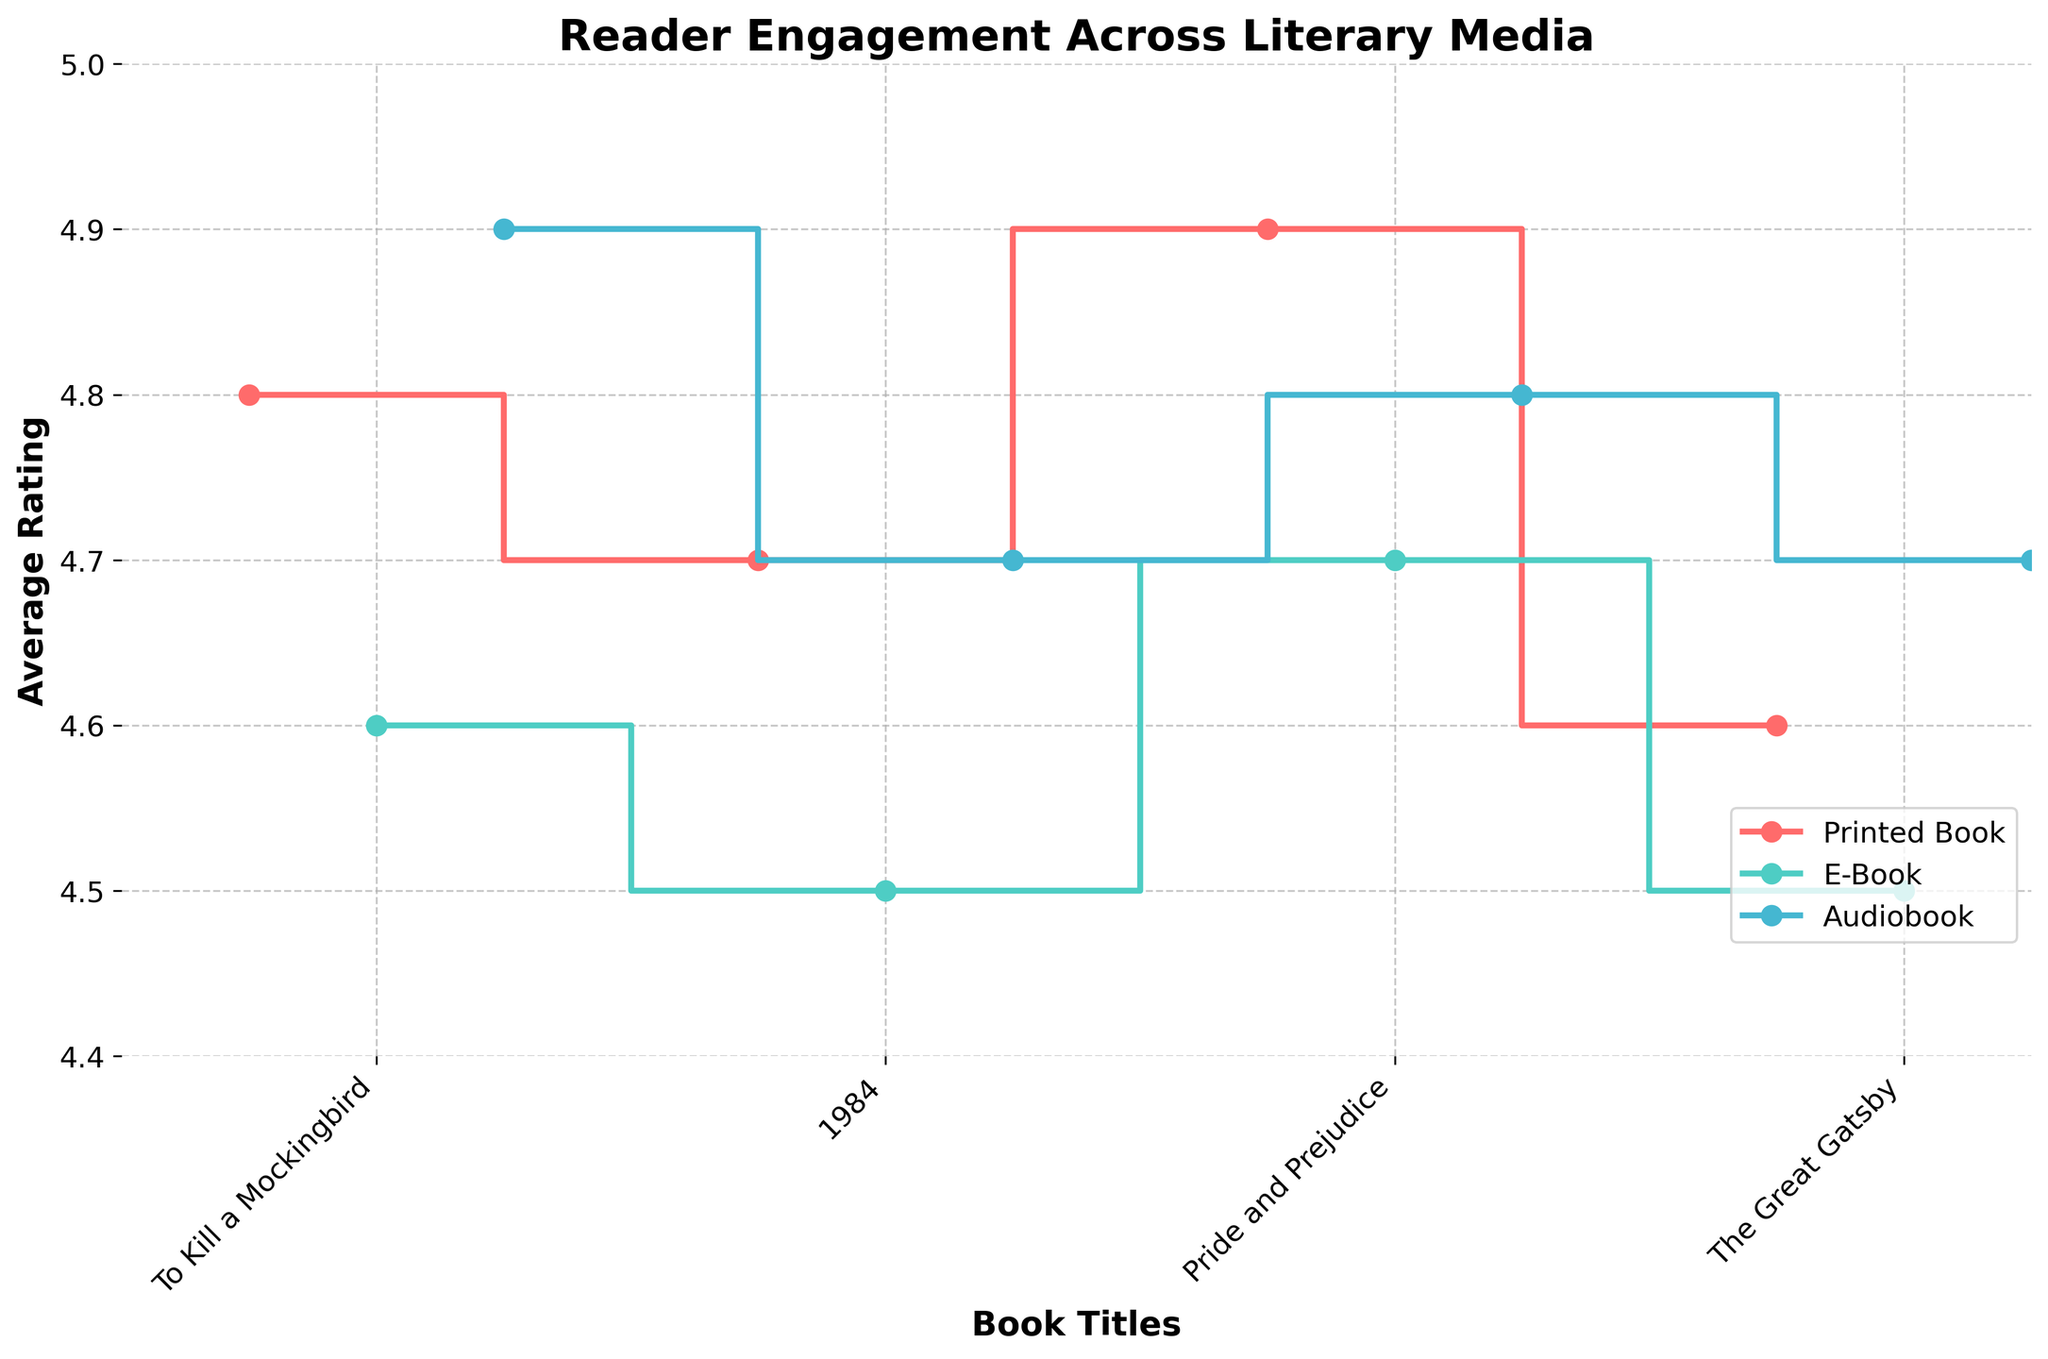What is the title of the figure? The title of the figure is displayed at the top of the plot. In this case, the title is "Reader Engagement Across Literary Media".
Answer: Reader Engagement Across Literary Media Which literary medium has the lowest average rating for "1984"? Looking at the step plot, the literary medium with the lowest step in the series for "1984" is the E-Book medium with an average rating of 4.5.
Answer: E-Book What is the range of average ratings on the Y-axis? The Y-axis shows the range of values from 4.4 to 5.0, as indicated by the tick marks and labels.
Answer: 4.4 to 5.0 Which book has the highest average rating for Audiobooks? The highest step on the step plot for Audiobooks is for "To Kill a Mockingbird", which has an average rating of 4.9.
Answer: To Kill a Mockingbird How many data points are there for each book title? Each book title has three data points, one for each literary medium: Printed Book, E-Book, and Audiobook.
Answer: 3 What is the average rating difference between Audiobook and E-Book for "The Great Gatsby"? The average rating for "The Great Gatsby" in Audiobook form is 4.7, and for E-Book form is 4.5. The difference is 4.7 - 4.5 = 0.2.
Answer: 0.2 Which book has a higher average rating in Printed Book form than in Audiobook form? Comparing the steps for Printed Book and Audiobook, "Pride and Prejudice" has a higher average rating in Printed Book form (4.9) than in Audiobook form (4.8).
Answer: Pride and Prejudice What is the overall trend in reader engagement across the different literary mediums? From the step plot, it can be observed that Audiobooks generally have high ratings, followed by Printed Books, and then E-Books, showing a trend where Audiobooks and Printed Books tend to be favored over E-Books in terms of average ratings.
Answer: Audiobooks > Printed Books > E-Books Which literary medium has the most consistent ratings across all books? By visually assessing the plot, the Audiobook medium shows relatively consistent high average ratings across all listed titles, with minor variation.
Answer: Audiobook 